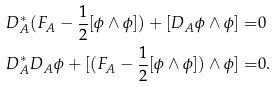Convert formula to latex. <formula><loc_0><loc_0><loc_500><loc_500>D ^ { * } _ { A } ( F _ { A } - \frac { 1 } { 2 } [ \phi \wedge \phi ] ) + [ D _ { A } \phi \wedge \phi ] = & 0 \\ D ^ { * } _ { A } D _ { A } \phi + [ ( F _ { A } - \frac { 1 } { 2 } [ \phi \wedge \phi ] ) \wedge \phi ] = & 0 .</formula> 